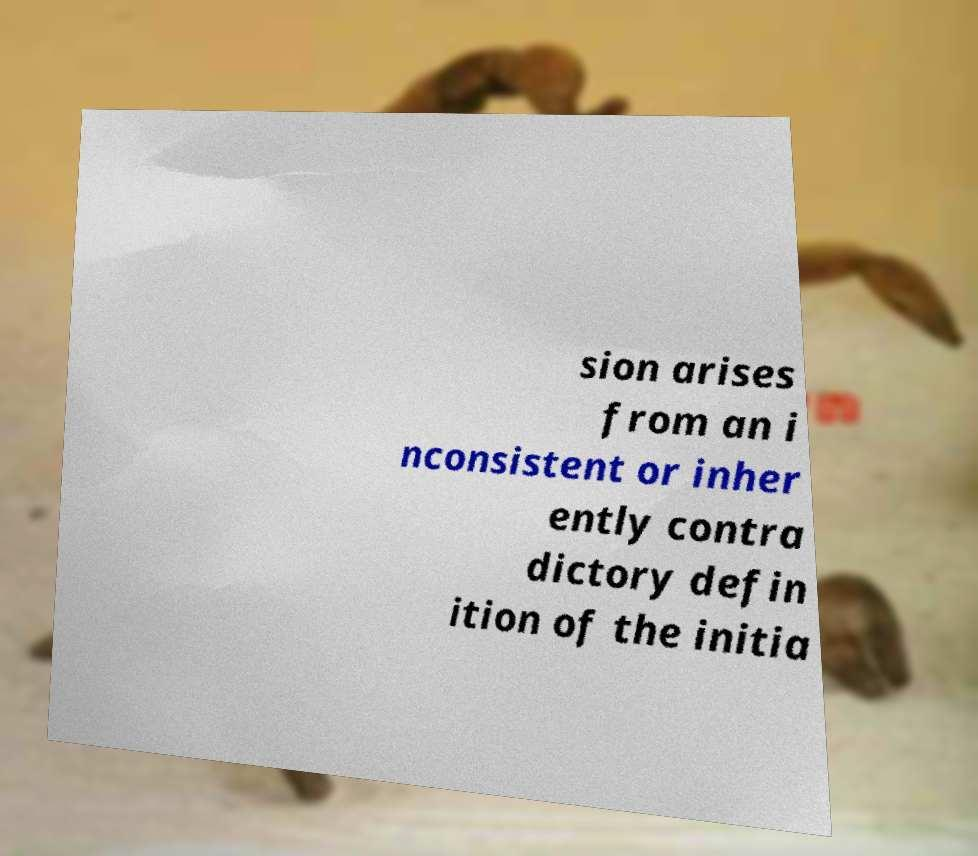Please identify and transcribe the text found in this image. sion arises from an i nconsistent or inher ently contra dictory defin ition of the initia 